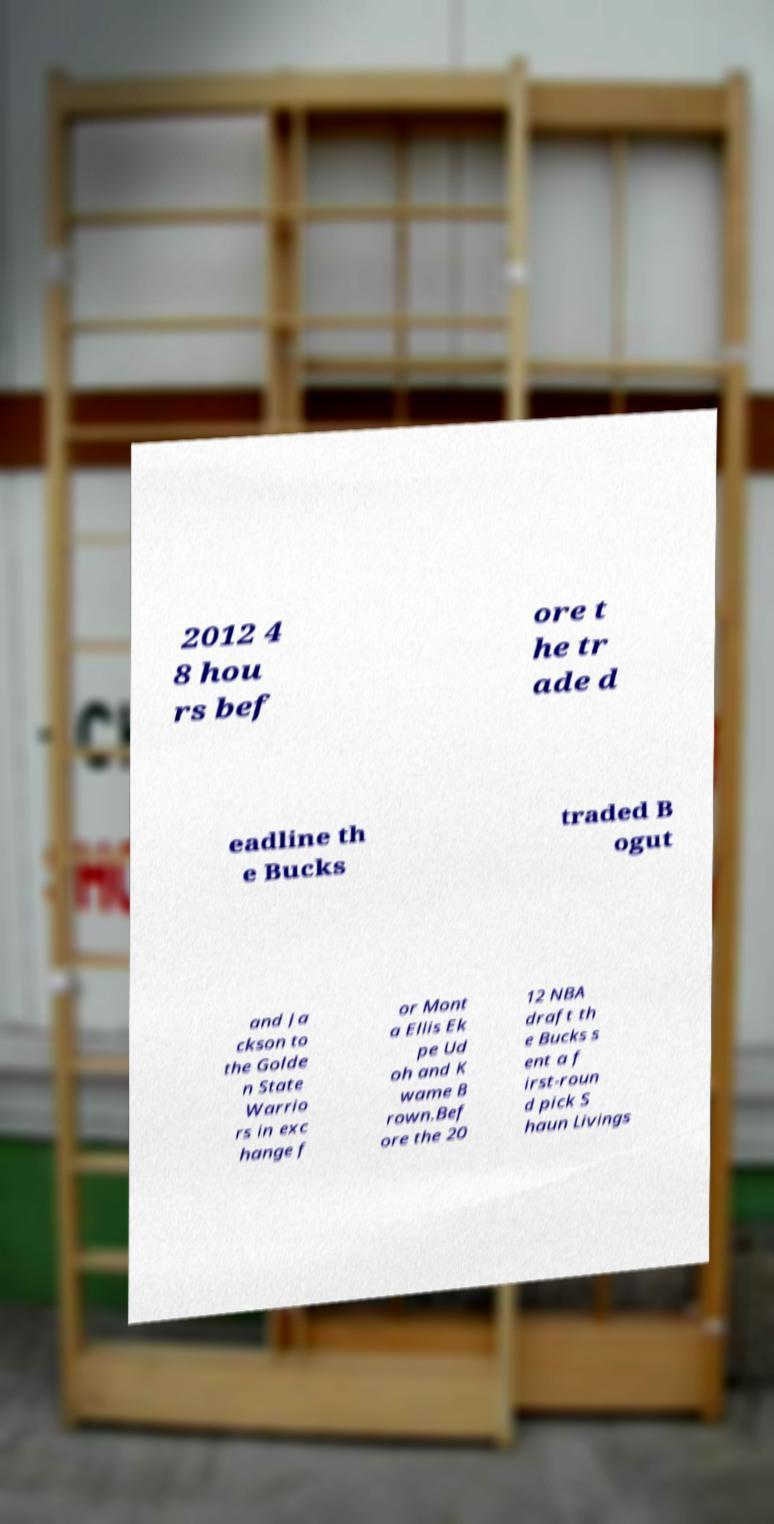There's text embedded in this image that I need extracted. Can you transcribe it verbatim? 2012 4 8 hou rs bef ore t he tr ade d eadline th e Bucks traded B ogut and Ja ckson to the Golde n State Warrio rs in exc hange f or Mont a Ellis Ek pe Ud oh and K wame B rown.Bef ore the 20 12 NBA draft th e Bucks s ent a f irst-roun d pick S haun Livings 